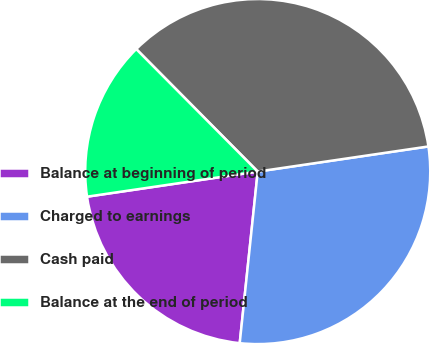Convert chart to OTSL. <chart><loc_0><loc_0><loc_500><loc_500><pie_chart><fcel>Balance at beginning of period<fcel>Charged to earnings<fcel>Cash paid<fcel>Balance at the end of period<nl><fcel>21.01%<fcel>28.99%<fcel>35.11%<fcel>14.89%<nl></chart> 